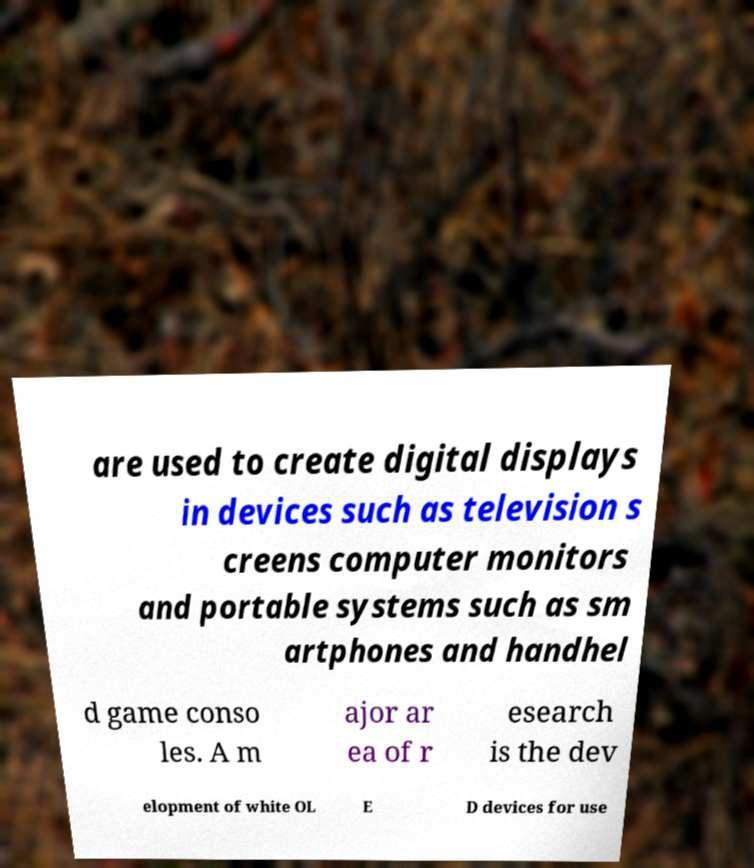What messages or text are displayed in this image? I need them in a readable, typed format. are used to create digital displays in devices such as television s creens computer monitors and portable systems such as sm artphones and handhel d game conso les. A m ajor ar ea of r esearch is the dev elopment of white OL E D devices for use 